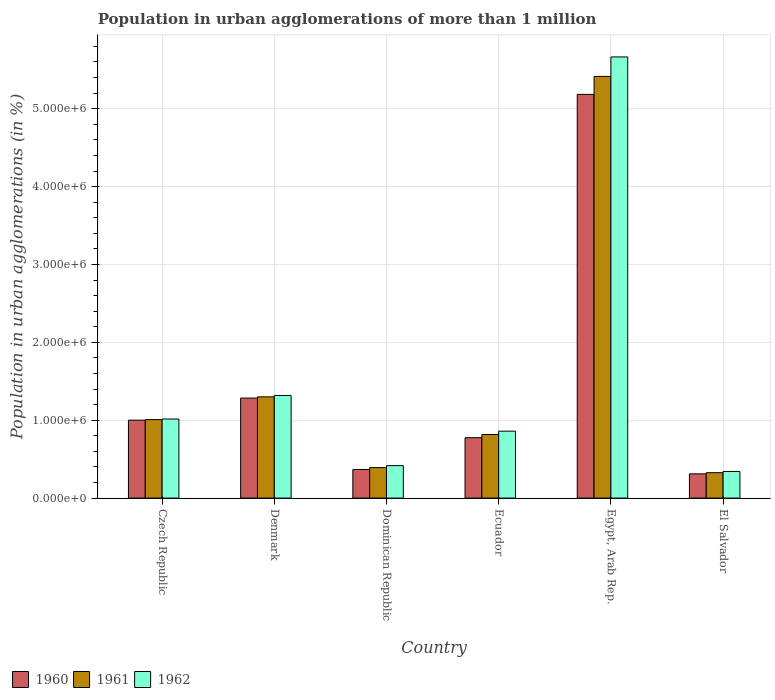How many bars are there on the 3rd tick from the right?
Ensure brevity in your answer.  3. What is the label of the 4th group of bars from the left?
Your answer should be compact. Ecuador. In how many cases, is the number of bars for a given country not equal to the number of legend labels?
Provide a short and direct response. 0. What is the population in urban agglomerations in 1960 in Denmark?
Make the answer very short. 1.28e+06. Across all countries, what is the maximum population in urban agglomerations in 1960?
Offer a very short reply. 5.18e+06. Across all countries, what is the minimum population in urban agglomerations in 1960?
Your response must be concise. 3.11e+05. In which country was the population in urban agglomerations in 1962 maximum?
Offer a terse response. Egypt, Arab Rep. In which country was the population in urban agglomerations in 1962 minimum?
Make the answer very short. El Salvador. What is the total population in urban agglomerations in 1962 in the graph?
Your answer should be compact. 9.62e+06. What is the difference between the population in urban agglomerations in 1960 in Dominican Republic and that in Egypt, Arab Rep.?
Your response must be concise. -4.82e+06. What is the difference between the population in urban agglomerations in 1961 in Egypt, Arab Rep. and the population in urban agglomerations in 1962 in Czech Republic?
Offer a terse response. 4.40e+06. What is the average population in urban agglomerations in 1962 per country?
Make the answer very short. 1.60e+06. What is the difference between the population in urban agglomerations of/in 1960 and population in urban agglomerations of/in 1961 in Egypt, Arab Rep.?
Offer a terse response. -2.31e+05. In how many countries, is the population in urban agglomerations in 1961 greater than 1000000 %?
Ensure brevity in your answer.  3. What is the ratio of the population in urban agglomerations in 1961 in Ecuador to that in Egypt, Arab Rep.?
Offer a very short reply. 0.15. Is the population in urban agglomerations in 1960 in Denmark less than that in Egypt, Arab Rep.?
Provide a succinct answer. Yes. Is the difference between the population in urban agglomerations in 1960 in Denmark and Ecuador greater than the difference between the population in urban agglomerations in 1961 in Denmark and Ecuador?
Your answer should be compact. Yes. What is the difference between the highest and the second highest population in urban agglomerations in 1960?
Your answer should be very brief. 4.18e+06. What is the difference between the highest and the lowest population in urban agglomerations in 1962?
Your answer should be very brief. 5.32e+06. In how many countries, is the population in urban agglomerations in 1961 greater than the average population in urban agglomerations in 1961 taken over all countries?
Ensure brevity in your answer.  1. Is the sum of the population in urban agglomerations in 1962 in Ecuador and El Salvador greater than the maximum population in urban agglomerations in 1961 across all countries?
Your answer should be compact. No. What does the 1st bar from the right in Egypt, Arab Rep. represents?
Make the answer very short. 1962. Is it the case that in every country, the sum of the population in urban agglomerations in 1960 and population in urban agglomerations in 1961 is greater than the population in urban agglomerations in 1962?
Keep it short and to the point. Yes. How many countries are there in the graph?
Your response must be concise. 6. How are the legend labels stacked?
Keep it short and to the point. Horizontal. What is the title of the graph?
Provide a succinct answer. Population in urban agglomerations of more than 1 million. What is the label or title of the Y-axis?
Offer a terse response. Population in urban agglomerations (in %). What is the Population in urban agglomerations (in %) of 1960 in Czech Republic?
Your answer should be compact. 1.00e+06. What is the Population in urban agglomerations (in %) of 1961 in Czech Republic?
Ensure brevity in your answer.  1.01e+06. What is the Population in urban agglomerations (in %) in 1962 in Czech Republic?
Ensure brevity in your answer.  1.02e+06. What is the Population in urban agglomerations (in %) in 1960 in Denmark?
Ensure brevity in your answer.  1.28e+06. What is the Population in urban agglomerations (in %) of 1961 in Denmark?
Keep it short and to the point. 1.30e+06. What is the Population in urban agglomerations (in %) of 1962 in Denmark?
Your response must be concise. 1.32e+06. What is the Population in urban agglomerations (in %) of 1960 in Dominican Republic?
Provide a short and direct response. 3.67e+05. What is the Population in urban agglomerations (in %) in 1961 in Dominican Republic?
Provide a succinct answer. 3.91e+05. What is the Population in urban agglomerations (in %) of 1962 in Dominican Republic?
Your answer should be very brief. 4.17e+05. What is the Population in urban agglomerations (in %) in 1960 in Ecuador?
Your answer should be very brief. 7.76e+05. What is the Population in urban agglomerations (in %) in 1961 in Ecuador?
Provide a short and direct response. 8.16e+05. What is the Population in urban agglomerations (in %) in 1962 in Ecuador?
Your answer should be very brief. 8.60e+05. What is the Population in urban agglomerations (in %) in 1960 in Egypt, Arab Rep.?
Keep it short and to the point. 5.18e+06. What is the Population in urban agglomerations (in %) in 1961 in Egypt, Arab Rep.?
Your answer should be very brief. 5.41e+06. What is the Population in urban agglomerations (in %) in 1962 in Egypt, Arab Rep.?
Give a very brief answer. 5.66e+06. What is the Population in urban agglomerations (in %) in 1960 in El Salvador?
Keep it short and to the point. 3.11e+05. What is the Population in urban agglomerations (in %) of 1961 in El Salvador?
Ensure brevity in your answer.  3.26e+05. What is the Population in urban agglomerations (in %) in 1962 in El Salvador?
Your response must be concise. 3.42e+05. Across all countries, what is the maximum Population in urban agglomerations (in %) in 1960?
Your answer should be compact. 5.18e+06. Across all countries, what is the maximum Population in urban agglomerations (in %) of 1961?
Your response must be concise. 5.41e+06. Across all countries, what is the maximum Population in urban agglomerations (in %) in 1962?
Offer a terse response. 5.66e+06. Across all countries, what is the minimum Population in urban agglomerations (in %) in 1960?
Offer a very short reply. 3.11e+05. Across all countries, what is the minimum Population in urban agglomerations (in %) in 1961?
Provide a succinct answer. 3.26e+05. Across all countries, what is the minimum Population in urban agglomerations (in %) of 1962?
Provide a short and direct response. 3.42e+05. What is the total Population in urban agglomerations (in %) of 1960 in the graph?
Provide a short and direct response. 8.92e+06. What is the total Population in urban agglomerations (in %) in 1961 in the graph?
Your response must be concise. 9.26e+06. What is the total Population in urban agglomerations (in %) of 1962 in the graph?
Provide a short and direct response. 9.62e+06. What is the difference between the Population in urban agglomerations (in %) of 1960 in Czech Republic and that in Denmark?
Your answer should be very brief. -2.84e+05. What is the difference between the Population in urban agglomerations (in %) of 1961 in Czech Republic and that in Denmark?
Ensure brevity in your answer.  -2.92e+05. What is the difference between the Population in urban agglomerations (in %) of 1962 in Czech Republic and that in Denmark?
Offer a terse response. -3.03e+05. What is the difference between the Population in urban agglomerations (in %) in 1960 in Czech Republic and that in Dominican Republic?
Provide a short and direct response. 6.34e+05. What is the difference between the Population in urban agglomerations (in %) in 1961 in Czech Republic and that in Dominican Republic?
Offer a terse response. 6.16e+05. What is the difference between the Population in urban agglomerations (in %) in 1962 in Czech Republic and that in Dominican Republic?
Provide a short and direct response. 5.98e+05. What is the difference between the Population in urban agglomerations (in %) of 1960 in Czech Republic and that in Ecuador?
Provide a short and direct response. 2.25e+05. What is the difference between the Population in urban agglomerations (in %) of 1961 in Czech Republic and that in Ecuador?
Your answer should be compact. 1.91e+05. What is the difference between the Population in urban agglomerations (in %) in 1962 in Czech Republic and that in Ecuador?
Offer a very short reply. 1.56e+05. What is the difference between the Population in urban agglomerations (in %) in 1960 in Czech Republic and that in Egypt, Arab Rep.?
Your answer should be compact. -4.18e+06. What is the difference between the Population in urban agglomerations (in %) of 1961 in Czech Republic and that in Egypt, Arab Rep.?
Give a very brief answer. -4.41e+06. What is the difference between the Population in urban agglomerations (in %) of 1962 in Czech Republic and that in Egypt, Arab Rep.?
Your answer should be very brief. -4.65e+06. What is the difference between the Population in urban agglomerations (in %) of 1960 in Czech Republic and that in El Salvador?
Make the answer very short. 6.90e+05. What is the difference between the Population in urban agglomerations (in %) in 1961 in Czech Republic and that in El Salvador?
Offer a very short reply. 6.82e+05. What is the difference between the Population in urban agglomerations (in %) of 1962 in Czech Republic and that in El Salvador?
Provide a short and direct response. 6.73e+05. What is the difference between the Population in urban agglomerations (in %) of 1960 in Denmark and that in Dominican Republic?
Provide a succinct answer. 9.17e+05. What is the difference between the Population in urban agglomerations (in %) of 1961 in Denmark and that in Dominican Republic?
Ensure brevity in your answer.  9.09e+05. What is the difference between the Population in urban agglomerations (in %) of 1962 in Denmark and that in Dominican Republic?
Give a very brief answer. 9.01e+05. What is the difference between the Population in urban agglomerations (in %) of 1960 in Denmark and that in Ecuador?
Provide a succinct answer. 5.09e+05. What is the difference between the Population in urban agglomerations (in %) in 1961 in Denmark and that in Ecuador?
Your response must be concise. 4.83e+05. What is the difference between the Population in urban agglomerations (in %) of 1962 in Denmark and that in Ecuador?
Make the answer very short. 4.58e+05. What is the difference between the Population in urban agglomerations (in %) of 1960 in Denmark and that in Egypt, Arab Rep.?
Provide a succinct answer. -3.90e+06. What is the difference between the Population in urban agglomerations (in %) of 1961 in Denmark and that in Egypt, Arab Rep.?
Make the answer very short. -4.11e+06. What is the difference between the Population in urban agglomerations (in %) in 1962 in Denmark and that in Egypt, Arab Rep.?
Your answer should be very brief. -4.35e+06. What is the difference between the Population in urban agglomerations (in %) in 1960 in Denmark and that in El Salvador?
Keep it short and to the point. 9.73e+05. What is the difference between the Population in urban agglomerations (in %) in 1961 in Denmark and that in El Salvador?
Keep it short and to the point. 9.74e+05. What is the difference between the Population in urban agglomerations (in %) of 1962 in Denmark and that in El Salvador?
Offer a very short reply. 9.76e+05. What is the difference between the Population in urban agglomerations (in %) in 1960 in Dominican Republic and that in Ecuador?
Offer a terse response. -4.08e+05. What is the difference between the Population in urban agglomerations (in %) of 1961 in Dominican Republic and that in Ecuador?
Make the answer very short. -4.25e+05. What is the difference between the Population in urban agglomerations (in %) in 1962 in Dominican Republic and that in Ecuador?
Provide a short and direct response. -4.43e+05. What is the difference between the Population in urban agglomerations (in %) of 1960 in Dominican Republic and that in Egypt, Arab Rep.?
Your answer should be very brief. -4.82e+06. What is the difference between the Population in urban agglomerations (in %) in 1961 in Dominican Republic and that in Egypt, Arab Rep.?
Offer a very short reply. -5.02e+06. What is the difference between the Population in urban agglomerations (in %) of 1962 in Dominican Republic and that in Egypt, Arab Rep.?
Provide a short and direct response. -5.25e+06. What is the difference between the Population in urban agglomerations (in %) in 1960 in Dominican Republic and that in El Salvador?
Offer a terse response. 5.61e+04. What is the difference between the Population in urban agglomerations (in %) of 1961 in Dominican Republic and that in El Salvador?
Ensure brevity in your answer.  6.52e+04. What is the difference between the Population in urban agglomerations (in %) in 1962 in Dominican Republic and that in El Salvador?
Provide a short and direct response. 7.48e+04. What is the difference between the Population in urban agglomerations (in %) in 1960 in Ecuador and that in Egypt, Arab Rep.?
Give a very brief answer. -4.41e+06. What is the difference between the Population in urban agglomerations (in %) in 1961 in Ecuador and that in Egypt, Arab Rep.?
Your answer should be compact. -4.60e+06. What is the difference between the Population in urban agglomerations (in %) of 1962 in Ecuador and that in Egypt, Arab Rep.?
Offer a terse response. -4.81e+06. What is the difference between the Population in urban agglomerations (in %) of 1960 in Ecuador and that in El Salvador?
Provide a short and direct response. 4.64e+05. What is the difference between the Population in urban agglomerations (in %) of 1961 in Ecuador and that in El Salvador?
Ensure brevity in your answer.  4.90e+05. What is the difference between the Population in urban agglomerations (in %) in 1962 in Ecuador and that in El Salvador?
Offer a terse response. 5.18e+05. What is the difference between the Population in urban agglomerations (in %) in 1960 in Egypt, Arab Rep. and that in El Salvador?
Provide a short and direct response. 4.87e+06. What is the difference between the Population in urban agglomerations (in %) in 1961 in Egypt, Arab Rep. and that in El Salvador?
Ensure brevity in your answer.  5.09e+06. What is the difference between the Population in urban agglomerations (in %) of 1962 in Egypt, Arab Rep. and that in El Salvador?
Provide a short and direct response. 5.32e+06. What is the difference between the Population in urban agglomerations (in %) in 1960 in Czech Republic and the Population in urban agglomerations (in %) in 1961 in Denmark?
Give a very brief answer. -2.99e+05. What is the difference between the Population in urban agglomerations (in %) in 1960 in Czech Republic and the Population in urban agglomerations (in %) in 1962 in Denmark?
Keep it short and to the point. -3.17e+05. What is the difference between the Population in urban agglomerations (in %) in 1961 in Czech Republic and the Population in urban agglomerations (in %) in 1962 in Denmark?
Offer a terse response. -3.10e+05. What is the difference between the Population in urban agglomerations (in %) in 1960 in Czech Republic and the Population in urban agglomerations (in %) in 1961 in Dominican Republic?
Your answer should be compact. 6.09e+05. What is the difference between the Population in urban agglomerations (in %) in 1960 in Czech Republic and the Population in urban agglomerations (in %) in 1962 in Dominican Republic?
Keep it short and to the point. 5.84e+05. What is the difference between the Population in urban agglomerations (in %) of 1961 in Czech Republic and the Population in urban agglomerations (in %) of 1962 in Dominican Republic?
Make the answer very short. 5.91e+05. What is the difference between the Population in urban agglomerations (in %) in 1960 in Czech Republic and the Population in urban agglomerations (in %) in 1961 in Ecuador?
Give a very brief answer. 1.84e+05. What is the difference between the Population in urban agglomerations (in %) in 1960 in Czech Republic and the Population in urban agglomerations (in %) in 1962 in Ecuador?
Ensure brevity in your answer.  1.41e+05. What is the difference between the Population in urban agglomerations (in %) in 1961 in Czech Republic and the Population in urban agglomerations (in %) in 1962 in Ecuador?
Your answer should be compact. 1.48e+05. What is the difference between the Population in urban agglomerations (in %) of 1960 in Czech Republic and the Population in urban agglomerations (in %) of 1961 in Egypt, Arab Rep.?
Provide a succinct answer. -4.41e+06. What is the difference between the Population in urban agglomerations (in %) in 1960 in Czech Republic and the Population in urban agglomerations (in %) in 1962 in Egypt, Arab Rep.?
Offer a very short reply. -4.66e+06. What is the difference between the Population in urban agglomerations (in %) of 1961 in Czech Republic and the Population in urban agglomerations (in %) of 1962 in Egypt, Arab Rep.?
Provide a succinct answer. -4.66e+06. What is the difference between the Population in urban agglomerations (in %) of 1960 in Czech Republic and the Population in urban agglomerations (in %) of 1961 in El Salvador?
Make the answer very short. 6.75e+05. What is the difference between the Population in urban agglomerations (in %) of 1960 in Czech Republic and the Population in urban agglomerations (in %) of 1962 in El Salvador?
Offer a very short reply. 6.59e+05. What is the difference between the Population in urban agglomerations (in %) in 1961 in Czech Republic and the Population in urban agglomerations (in %) in 1962 in El Salvador?
Make the answer very short. 6.66e+05. What is the difference between the Population in urban agglomerations (in %) of 1960 in Denmark and the Population in urban agglomerations (in %) of 1961 in Dominican Republic?
Your response must be concise. 8.93e+05. What is the difference between the Population in urban agglomerations (in %) of 1960 in Denmark and the Population in urban agglomerations (in %) of 1962 in Dominican Republic?
Provide a succinct answer. 8.68e+05. What is the difference between the Population in urban agglomerations (in %) in 1961 in Denmark and the Population in urban agglomerations (in %) in 1962 in Dominican Republic?
Ensure brevity in your answer.  8.83e+05. What is the difference between the Population in urban agglomerations (in %) in 1960 in Denmark and the Population in urban agglomerations (in %) in 1961 in Ecuador?
Ensure brevity in your answer.  4.68e+05. What is the difference between the Population in urban agglomerations (in %) in 1960 in Denmark and the Population in urban agglomerations (in %) in 1962 in Ecuador?
Your response must be concise. 4.25e+05. What is the difference between the Population in urban agglomerations (in %) in 1961 in Denmark and the Population in urban agglomerations (in %) in 1962 in Ecuador?
Your response must be concise. 4.40e+05. What is the difference between the Population in urban agglomerations (in %) in 1960 in Denmark and the Population in urban agglomerations (in %) in 1961 in Egypt, Arab Rep.?
Your answer should be very brief. -4.13e+06. What is the difference between the Population in urban agglomerations (in %) in 1960 in Denmark and the Population in urban agglomerations (in %) in 1962 in Egypt, Arab Rep.?
Offer a terse response. -4.38e+06. What is the difference between the Population in urban agglomerations (in %) of 1961 in Denmark and the Population in urban agglomerations (in %) of 1962 in Egypt, Arab Rep.?
Your answer should be compact. -4.36e+06. What is the difference between the Population in urban agglomerations (in %) in 1960 in Denmark and the Population in urban agglomerations (in %) in 1961 in El Salvador?
Your response must be concise. 9.58e+05. What is the difference between the Population in urban agglomerations (in %) of 1960 in Denmark and the Population in urban agglomerations (in %) of 1962 in El Salvador?
Give a very brief answer. 9.42e+05. What is the difference between the Population in urban agglomerations (in %) in 1961 in Denmark and the Population in urban agglomerations (in %) in 1962 in El Salvador?
Provide a short and direct response. 9.58e+05. What is the difference between the Population in urban agglomerations (in %) of 1960 in Dominican Republic and the Population in urban agglomerations (in %) of 1961 in Ecuador?
Offer a very short reply. -4.49e+05. What is the difference between the Population in urban agglomerations (in %) in 1960 in Dominican Republic and the Population in urban agglomerations (in %) in 1962 in Ecuador?
Your answer should be compact. -4.92e+05. What is the difference between the Population in urban agglomerations (in %) of 1961 in Dominican Republic and the Population in urban agglomerations (in %) of 1962 in Ecuador?
Offer a terse response. -4.68e+05. What is the difference between the Population in urban agglomerations (in %) of 1960 in Dominican Republic and the Population in urban agglomerations (in %) of 1961 in Egypt, Arab Rep.?
Ensure brevity in your answer.  -5.05e+06. What is the difference between the Population in urban agglomerations (in %) in 1960 in Dominican Republic and the Population in urban agglomerations (in %) in 1962 in Egypt, Arab Rep.?
Provide a short and direct response. -5.30e+06. What is the difference between the Population in urban agglomerations (in %) in 1961 in Dominican Republic and the Population in urban agglomerations (in %) in 1962 in Egypt, Arab Rep.?
Keep it short and to the point. -5.27e+06. What is the difference between the Population in urban agglomerations (in %) of 1960 in Dominican Republic and the Population in urban agglomerations (in %) of 1961 in El Salvador?
Your answer should be compact. 4.11e+04. What is the difference between the Population in urban agglomerations (in %) in 1960 in Dominican Republic and the Population in urban agglomerations (in %) in 1962 in El Salvador?
Offer a very short reply. 2.53e+04. What is the difference between the Population in urban agglomerations (in %) in 1961 in Dominican Republic and the Population in urban agglomerations (in %) in 1962 in El Salvador?
Give a very brief answer. 4.94e+04. What is the difference between the Population in urban agglomerations (in %) in 1960 in Ecuador and the Population in urban agglomerations (in %) in 1961 in Egypt, Arab Rep.?
Give a very brief answer. -4.64e+06. What is the difference between the Population in urban agglomerations (in %) in 1960 in Ecuador and the Population in urban agglomerations (in %) in 1962 in Egypt, Arab Rep.?
Make the answer very short. -4.89e+06. What is the difference between the Population in urban agglomerations (in %) in 1961 in Ecuador and the Population in urban agglomerations (in %) in 1962 in Egypt, Arab Rep.?
Give a very brief answer. -4.85e+06. What is the difference between the Population in urban agglomerations (in %) in 1960 in Ecuador and the Population in urban agglomerations (in %) in 1961 in El Salvador?
Your response must be concise. 4.49e+05. What is the difference between the Population in urban agglomerations (in %) of 1960 in Ecuador and the Population in urban agglomerations (in %) of 1962 in El Salvador?
Offer a terse response. 4.34e+05. What is the difference between the Population in urban agglomerations (in %) of 1961 in Ecuador and the Population in urban agglomerations (in %) of 1962 in El Salvador?
Your answer should be very brief. 4.74e+05. What is the difference between the Population in urban agglomerations (in %) in 1960 in Egypt, Arab Rep. and the Population in urban agglomerations (in %) in 1961 in El Salvador?
Give a very brief answer. 4.86e+06. What is the difference between the Population in urban agglomerations (in %) in 1960 in Egypt, Arab Rep. and the Population in urban agglomerations (in %) in 1962 in El Salvador?
Provide a short and direct response. 4.84e+06. What is the difference between the Population in urban agglomerations (in %) in 1961 in Egypt, Arab Rep. and the Population in urban agglomerations (in %) in 1962 in El Salvador?
Make the answer very short. 5.07e+06. What is the average Population in urban agglomerations (in %) of 1960 per country?
Make the answer very short. 1.49e+06. What is the average Population in urban agglomerations (in %) in 1961 per country?
Offer a terse response. 1.54e+06. What is the average Population in urban agglomerations (in %) in 1962 per country?
Your answer should be compact. 1.60e+06. What is the difference between the Population in urban agglomerations (in %) in 1960 and Population in urban agglomerations (in %) in 1961 in Czech Republic?
Provide a succinct answer. -7004. What is the difference between the Population in urban agglomerations (in %) of 1960 and Population in urban agglomerations (in %) of 1962 in Czech Republic?
Make the answer very short. -1.44e+04. What is the difference between the Population in urban agglomerations (in %) of 1961 and Population in urban agglomerations (in %) of 1962 in Czech Republic?
Provide a succinct answer. -7379. What is the difference between the Population in urban agglomerations (in %) of 1960 and Population in urban agglomerations (in %) of 1961 in Denmark?
Make the answer very short. -1.55e+04. What is the difference between the Population in urban agglomerations (in %) in 1960 and Population in urban agglomerations (in %) in 1962 in Denmark?
Offer a terse response. -3.34e+04. What is the difference between the Population in urban agglomerations (in %) of 1961 and Population in urban agglomerations (in %) of 1962 in Denmark?
Your response must be concise. -1.79e+04. What is the difference between the Population in urban agglomerations (in %) in 1960 and Population in urban agglomerations (in %) in 1961 in Dominican Republic?
Provide a succinct answer. -2.41e+04. What is the difference between the Population in urban agglomerations (in %) in 1960 and Population in urban agglomerations (in %) in 1962 in Dominican Republic?
Provide a short and direct response. -4.95e+04. What is the difference between the Population in urban agglomerations (in %) of 1961 and Population in urban agglomerations (in %) of 1962 in Dominican Republic?
Your answer should be compact. -2.54e+04. What is the difference between the Population in urban agglomerations (in %) in 1960 and Population in urban agglomerations (in %) in 1961 in Ecuador?
Offer a very short reply. -4.09e+04. What is the difference between the Population in urban agglomerations (in %) in 1960 and Population in urban agglomerations (in %) in 1962 in Ecuador?
Give a very brief answer. -8.41e+04. What is the difference between the Population in urban agglomerations (in %) of 1961 and Population in urban agglomerations (in %) of 1962 in Ecuador?
Give a very brief answer. -4.32e+04. What is the difference between the Population in urban agglomerations (in %) of 1960 and Population in urban agglomerations (in %) of 1961 in Egypt, Arab Rep.?
Offer a terse response. -2.31e+05. What is the difference between the Population in urban agglomerations (in %) in 1960 and Population in urban agglomerations (in %) in 1962 in Egypt, Arab Rep.?
Keep it short and to the point. -4.81e+05. What is the difference between the Population in urban agglomerations (in %) of 1961 and Population in urban agglomerations (in %) of 1962 in Egypt, Arab Rep.?
Give a very brief answer. -2.50e+05. What is the difference between the Population in urban agglomerations (in %) of 1960 and Population in urban agglomerations (in %) of 1961 in El Salvador?
Offer a terse response. -1.50e+04. What is the difference between the Population in urban agglomerations (in %) in 1960 and Population in urban agglomerations (in %) in 1962 in El Salvador?
Your answer should be very brief. -3.08e+04. What is the difference between the Population in urban agglomerations (in %) of 1961 and Population in urban agglomerations (in %) of 1962 in El Salvador?
Provide a short and direct response. -1.58e+04. What is the ratio of the Population in urban agglomerations (in %) of 1960 in Czech Republic to that in Denmark?
Offer a terse response. 0.78. What is the ratio of the Population in urban agglomerations (in %) of 1961 in Czech Republic to that in Denmark?
Make the answer very short. 0.78. What is the ratio of the Population in urban agglomerations (in %) of 1962 in Czech Republic to that in Denmark?
Keep it short and to the point. 0.77. What is the ratio of the Population in urban agglomerations (in %) of 1960 in Czech Republic to that in Dominican Republic?
Your response must be concise. 2.72. What is the ratio of the Population in urban agglomerations (in %) in 1961 in Czech Republic to that in Dominican Republic?
Give a very brief answer. 2.57. What is the ratio of the Population in urban agglomerations (in %) of 1962 in Czech Republic to that in Dominican Republic?
Ensure brevity in your answer.  2.44. What is the ratio of the Population in urban agglomerations (in %) in 1960 in Czech Republic to that in Ecuador?
Ensure brevity in your answer.  1.29. What is the ratio of the Population in urban agglomerations (in %) of 1961 in Czech Republic to that in Ecuador?
Your answer should be very brief. 1.23. What is the ratio of the Population in urban agglomerations (in %) in 1962 in Czech Republic to that in Ecuador?
Provide a short and direct response. 1.18. What is the ratio of the Population in urban agglomerations (in %) in 1960 in Czech Republic to that in Egypt, Arab Rep.?
Keep it short and to the point. 0.19. What is the ratio of the Population in urban agglomerations (in %) in 1961 in Czech Republic to that in Egypt, Arab Rep.?
Your response must be concise. 0.19. What is the ratio of the Population in urban agglomerations (in %) of 1962 in Czech Republic to that in Egypt, Arab Rep.?
Offer a very short reply. 0.18. What is the ratio of the Population in urban agglomerations (in %) in 1960 in Czech Republic to that in El Salvador?
Ensure brevity in your answer.  3.22. What is the ratio of the Population in urban agglomerations (in %) in 1961 in Czech Republic to that in El Salvador?
Your answer should be compact. 3.09. What is the ratio of the Population in urban agglomerations (in %) in 1962 in Czech Republic to that in El Salvador?
Your response must be concise. 2.97. What is the ratio of the Population in urban agglomerations (in %) in 1960 in Denmark to that in Dominican Republic?
Your answer should be compact. 3.5. What is the ratio of the Population in urban agglomerations (in %) in 1961 in Denmark to that in Dominican Republic?
Provide a short and direct response. 3.32. What is the ratio of the Population in urban agglomerations (in %) of 1962 in Denmark to that in Dominican Republic?
Your answer should be very brief. 3.16. What is the ratio of the Population in urban agglomerations (in %) in 1960 in Denmark to that in Ecuador?
Make the answer very short. 1.66. What is the ratio of the Population in urban agglomerations (in %) of 1961 in Denmark to that in Ecuador?
Provide a short and direct response. 1.59. What is the ratio of the Population in urban agglomerations (in %) of 1962 in Denmark to that in Ecuador?
Give a very brief answer. 1.53. What is the ratio of the Population in urban agglomerations (in %) in 1960 in Denmark to that in Egypt, Arab Rep.?
Offer a very short reply. 0.25. What is the ratio of the Population in urban agglomerations (in %) of 1961 in Denmark to that in Egypt, Arab Rep.?
Make the answer very short. 0.24. What is the ratio of the Population in urban agglomerations (in %) of 1962 in Denmark to that in Egypt, Arab Rep.?
Your answer should be very brief. 0.23. What is the ratio of the Population in urban agglomerations (in %) in 1960 in Denmark to that in El Salvador?
Your answer should be compact. 4.13. What is the ratio of the Population in urban agglomerations (in %) in 1961 in Denmark to that in El Salvador?
Your answer should be very brief. 3.98. What is the ratio of the Population in urban agglomerations (in %) in 1962 in Denmark to that in El Salvador?
Your answer should be compact. 3.85. What is the ratio of the Population in urban agglomerations (in %) in 1960 in Dominican Republic to that in Ecuador?
Your response must be concise. 0.47. What is the ratio of the Population in urban agglomerations (in %) of 1961 in Dominican Republic to that in Ecuador?
Offer a terse response. 0.48. What is the ratio of the Population in urban agglomerations (in %) of 1962 in Dominican Republic to that in Ecuador?
Make the answer very short. 0.48. What is the ratio of the Population in urban agglomerations (in %) of 1960 in Dominican Republic to that in Egypt, Arab Rep.?
Your answer should be compact. 0.07. What is the ratio of the Population in urban agglomerations (in %) in 1961 in Dominican Republic to that in Egypt, Arab Rep.?
Keep it short and to the point. 0.07. What is the ratio of the Population in urban agglomerations (in %) in 1962 in Dominican Republic to that in Egypt, Arab Rep.?
Your response must be concise. 0.07. What is the ratio of the Population in urban agglomerations (in %) in 1960 in Dominican Republic to that in El Salvador?
Provide a succinct answer. 1.18. What is the ratio of the Population in urban agglomerations (in %) in 1961 in Dominican Republic to that in El Salvador?
Your answer should be very brief. 1.2. What is the ratio of the Population in urban agglomerations (in %) of 1962 in Dominican Republic to that in El Salvador?
Make the answer very short. 1.22. What is the ratio of the Population in urban agglomerations (in %) in 1960 in Ecuador to that in Egypt, Arab Rep.?
Your answer should be very brief. 0.15. What is the ratio of the Population in urban agglomerations (in %) of 1961 in Ecuador to that in Egypt, Arab Rep.?
Provide a short and direct response. 0.15. What is the ratio of the Population in urban agglomerations (in %) of 1962 in Ecuador to that in Egypt, Arab Rep.?
Ensure brevity in your answer.  0.15. What is the ratio of the Population in urban agglomerations (in %) in 1960 in Ecuador to that in El Salvador?
Ensure brevity in your answer.  2.49. What is the ratio of the Population in urban agglomerations (in %) in 1961 in Ecuador to that in El Salvador?
Keep it short and to the point. 2.5. What is the ratio of the Population in urban agglomerations (in %) of 1962 in Ecuador to that in El Salvador?
Offer a very short reply. 2.51. What is the ratio of the Population in urban agglomerations (in %) in 1960 in Egypt, Arab Rep. to that in El Salvador?
Offer a terse response. 16.66. What is the ratio of the Population in urban agglomerations (in %) in 1961 in Egypt, Arab Rep. to that in El Salvador?
Give a very brief answer. 16.6. What is the ratio of the Population in urban agglomerations (in %) in 1962 in Egypt, Arab Rep. to that in El Salvador?
Ensure brevity in your answer.  16.56. What is the difference between the highest and the second highest Population in urban agglomerations (in %) in 1960?
Your answer should be very brief. 3.90e+06. What is the difference between the highest and the second highest Population in urban agglomerations (in %) of 1961?
Keep it short and to the point. 4.11e+06. What is the difference between the highest and the second highest Population in urban agglomerations (in %) in 1962?
Offer a very short reply. 4.35e+06. What is the difference between the highest and the lowest Population in urban agglomerations (in %) of 1960?
Make the answer very short. 4.87e+06. What is the difference between the highest and the lowest Population in urban agglomerations (in %) in 1961?
Give a very brief answer. 5.09e+06. What is the difference between the highest and the lowest Population in urban agglomerations (in %) of 1962?
Your response must be concise. 5.32e+06. 